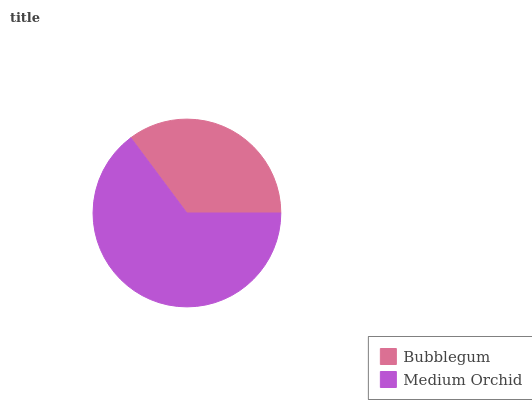Is Bubblegum the minimum?
Answer yes or no. Yes. Is Medium Orchid the maximum?
Answer yes or no. Yes. Is Medium Orchid the minimum?
Answer yes or no. No. Is Medium Orchid greater than Bubblegum?
Answer yes or no. Yes. Is Bubblegum less than Medium Orchid?
Answer yes or no. Yes. Is Bubblegum greater than Medium Orchid?
Answer yes or no. No. Is Medium Orchid less than Bubblegum?
Answer yes or no. No. Is Medium Orchid the high median?
Answer yes or no. Yes. Is Bubblegum the low median?
Answer yes or no. Yes. Is Bubblegum the high median?
Answer yes or no. No. Is Medium Orchid the low median?
Answer yes or no. No. 